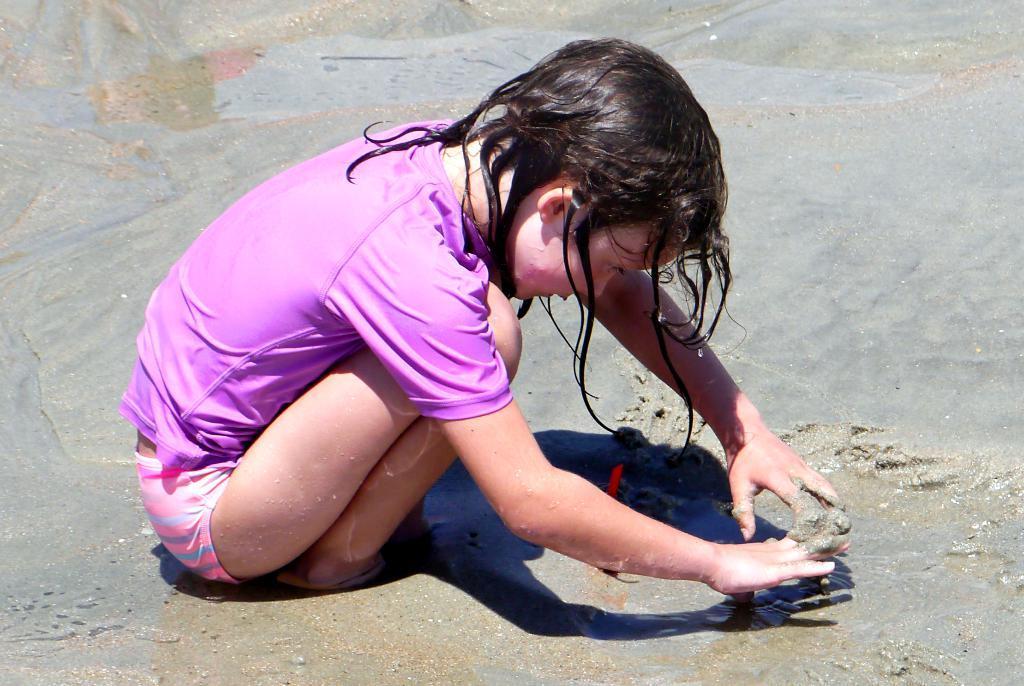Please provide a concise description of this image. In this image there is a child, sand and water. 